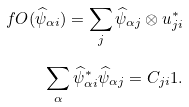<formula> <loc_0><loc_0><loc_500><loc_500>\ f O ( \widehat { \psi } _ { \alpha i } ) = \sum _ { j } \widehat { \psi } _ { \alpha j } \otimes u _ { j i } ^ { * } \\ \sum _ { \alpha } \widehat { \psi } _ { \alpha i } ^ { * } \widehat { \psi } _ { \alpha j } = C _ { j i } 1 .</formula> 